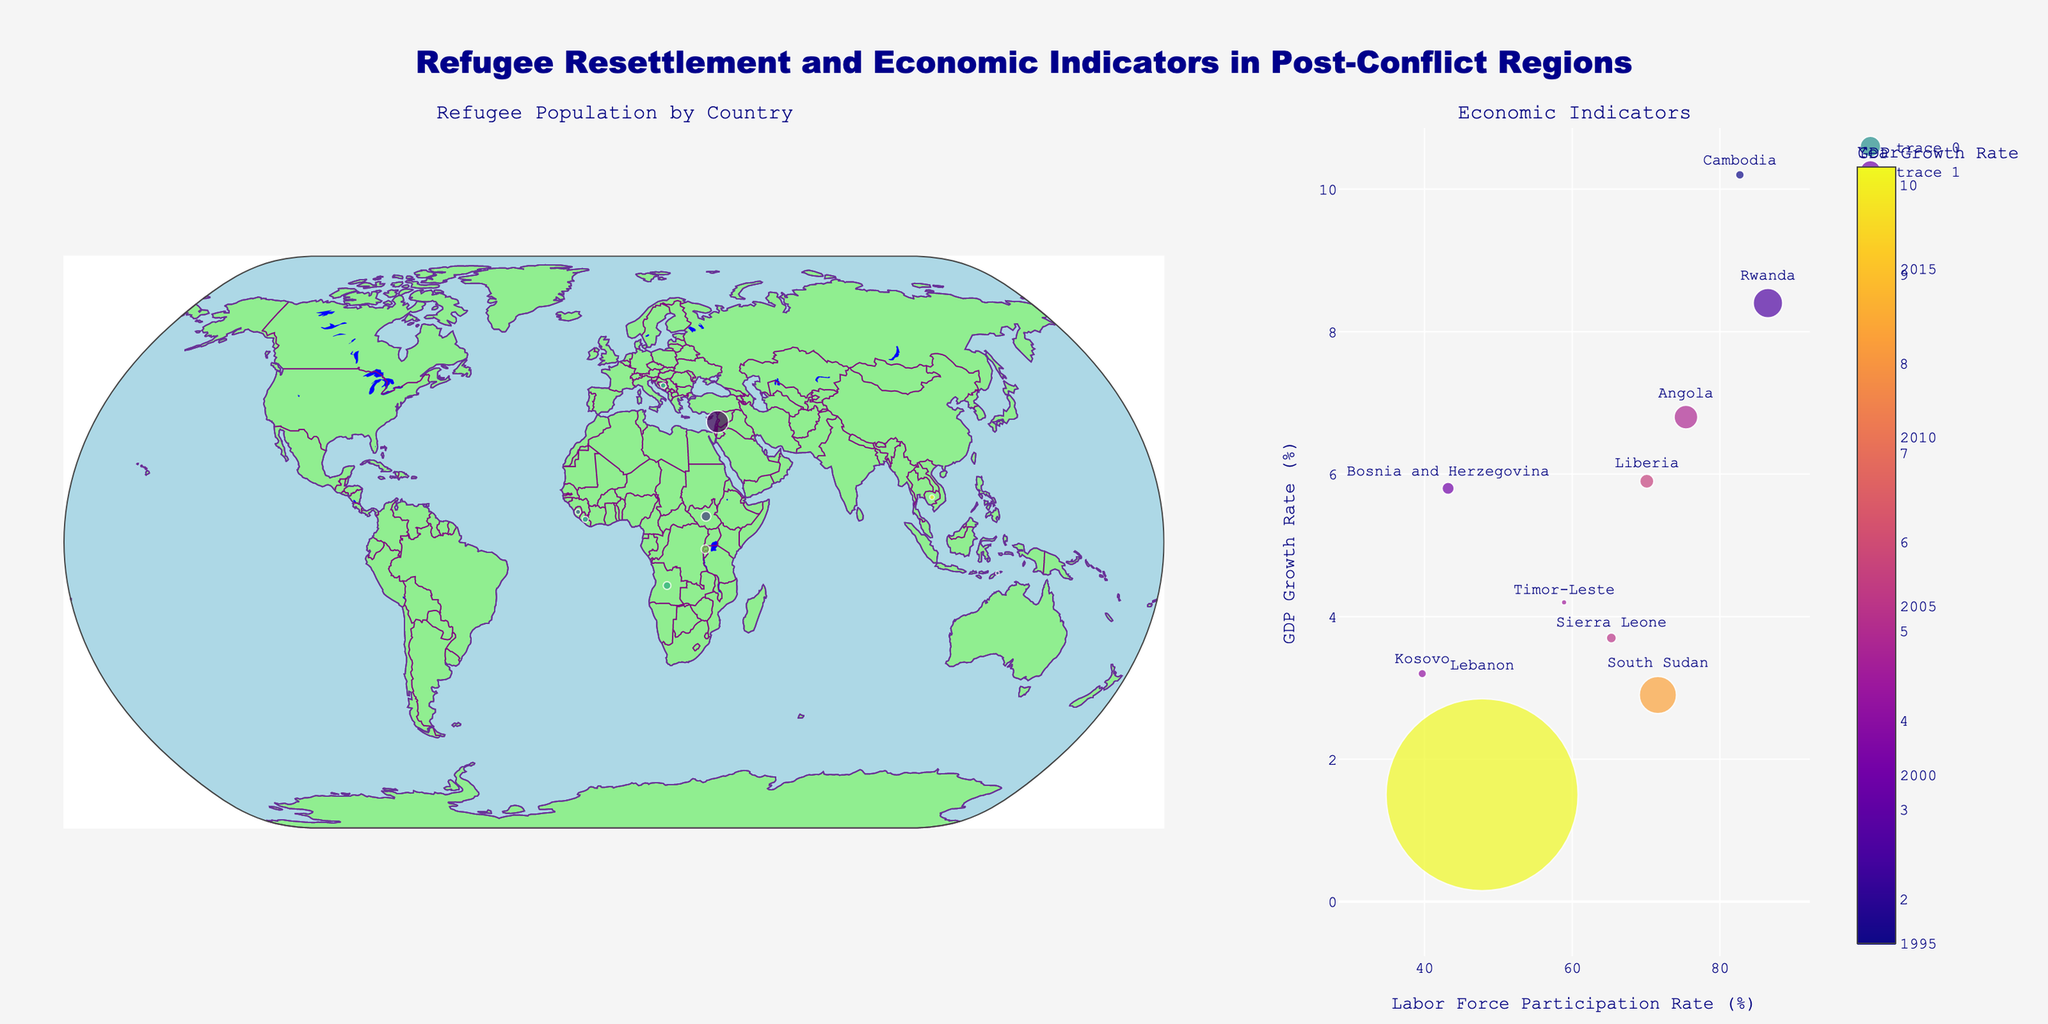What is the title of the figure? The title of the figure is located at the top center of the plot. It provides a summary description of the entire figure.
Answer: Refugee Resettlement and Economic Indicators in Post-Conflict Regions How many countries have a GDP growth rate below 5%? Count the number of countries where the marker color in the map on the left and the y-values in the scatter plot on the right are below 5%.
Answer: 4 Which country has the highest refugee population? The size of the markers on both the map and the scatter plot represents the refugee population. The largest marker indicates the highest refugee population.
Answer: Lebanon What is the relationship between GDP growth rate and labor force participation rate? Observe the scatter plot on the right. Analyze the trend by looking at how the y-values (GDP Growth Rate) change with respect to the x-values (Labor Force Participation Rate).
Answer: There is no clear linear relationship Which country has the highest labor force participation rate and what is its GDP growth rate? Locate the data point with the highest x-value (Labor Force Participation Rate) on the scatter plot and check its corresponding y-value (GDP Growth Rate).
Answer: Rwanda, 8.4% How does the GDP growth rate of Lebanon compare to that of South Sudan? Compare the y-values (GDP Growth Rate) of Lebanon and South Sudan on the scatter plot. Lebanon has a data point colored in darker shade indicating a higher refugee population while South Sudan's point is lighter and smaller.
Answer: Lebanon's GDP growth rate is higher than South Sudan's What is the GDP growth rate range across the countries? Identify the minimum and maximum y-values (GDP Growth Rate) on the scatter plot to determine the range.
Answer: 1.5% to 10.2% Which country's data point is the oldest, and what are its economic indicators? Check the color bar on the scatter plot to see which color represents the earliest year, and identify the corresponding country and its data on the x and y axes.
Answer: Cambodia, Labor Force Participation Rate: 82.7%, GDP Growth Rate: 10.2% Which two countries have the most similar labor force participation rates, and what are their corresponding GDP growth rates? Compare x-values (Labor Force Participation Rate) and find the two closest points on the scatter plot, then check their y-values (GDP Growth Rate).
Answer: Angola and South Sudan, GDP Growth Rates: 6.8% and 2.9% 